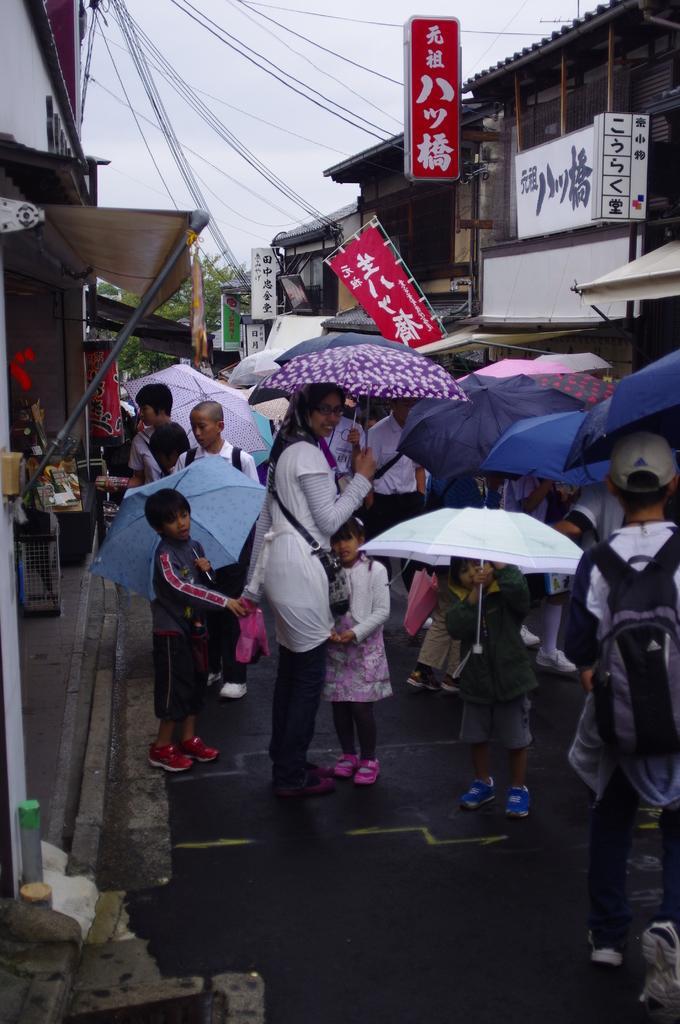In one or two sentences, can you explain what this image depicts? In this picture I can see people standing on the surface and holding umbrellas. I can see the buildings on the right side and left side. I can see hoardings. I can see electric wires. 